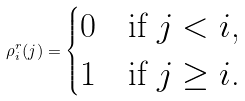<formula> <loc_0><loc_0><loc_500><loc_500>\rho ^ { r } _ { i } ( j ) = \begin{cases} 0 & \text {if $j< i$,} \\ 1 & \text {if $j\geq i$.} \end{cases}</formula> 